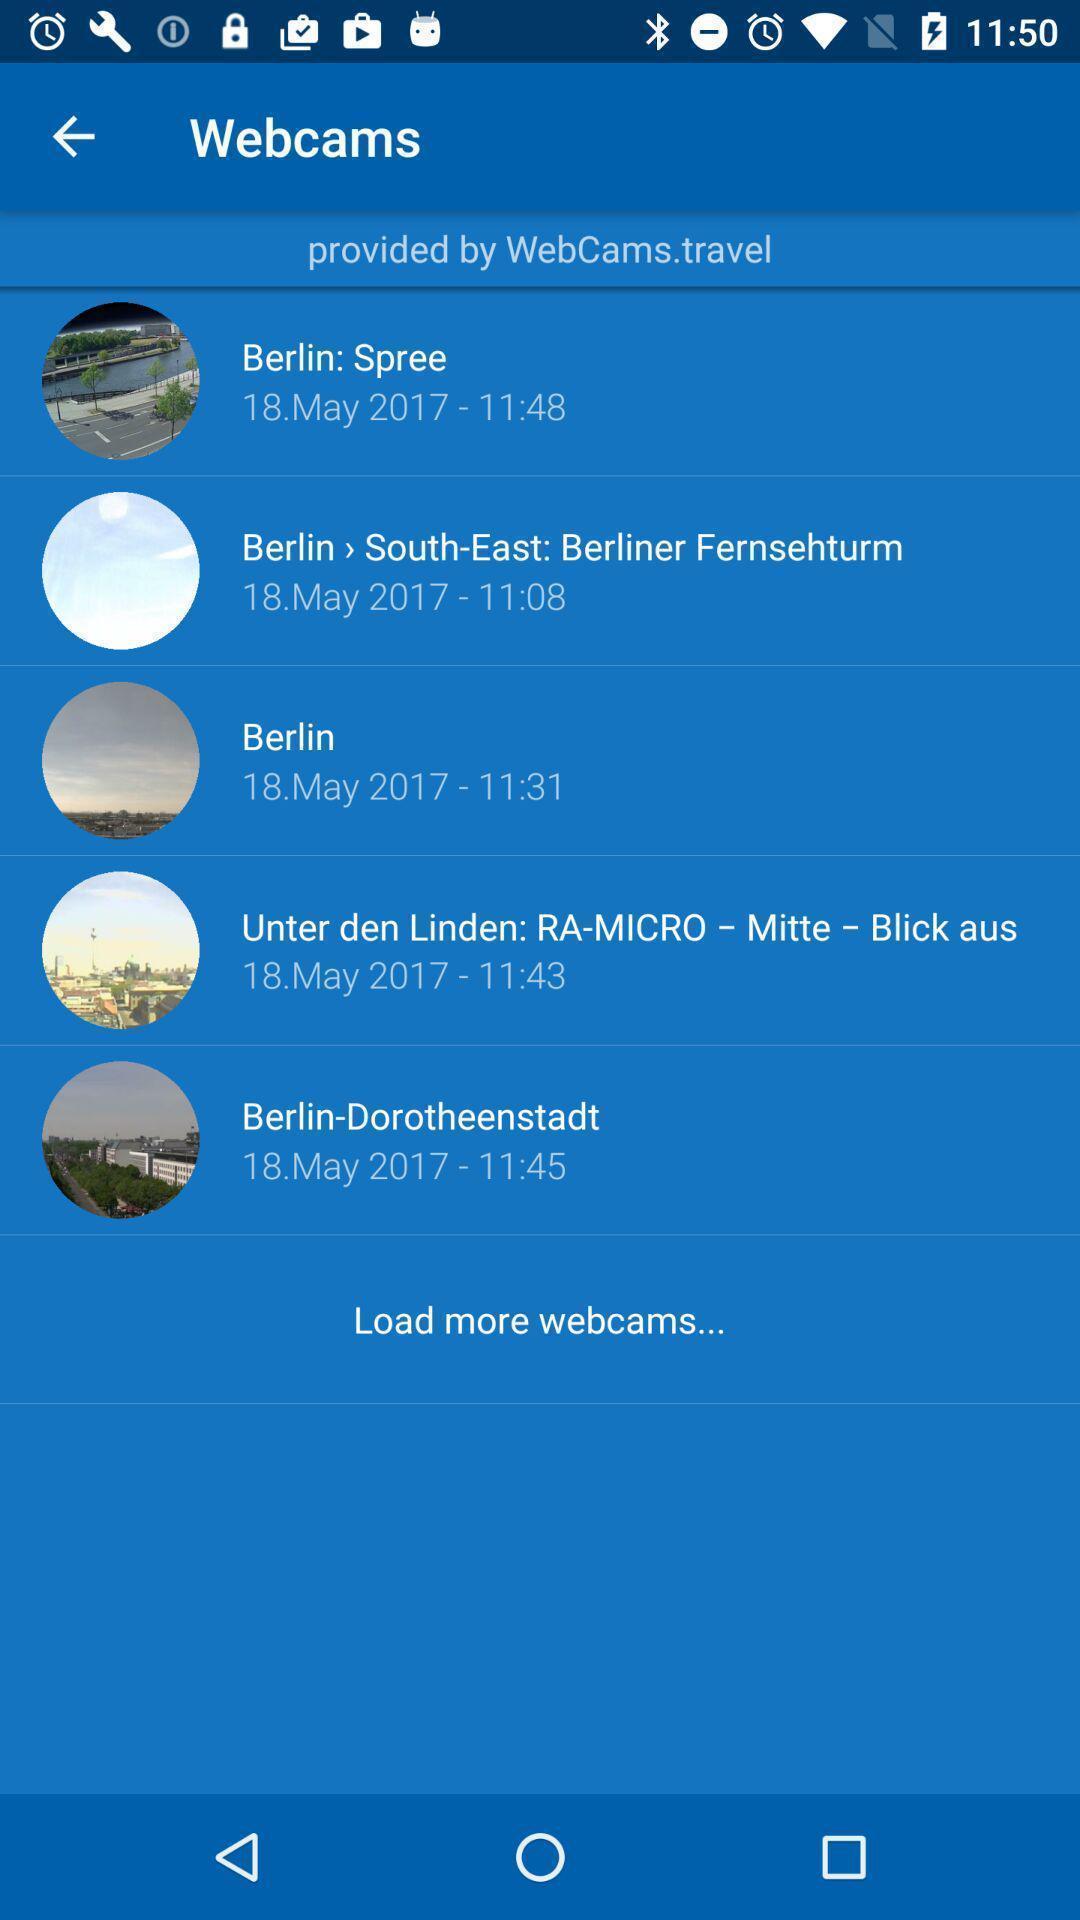Describe this image in words. Provided by webcams travel list showing in this page. 